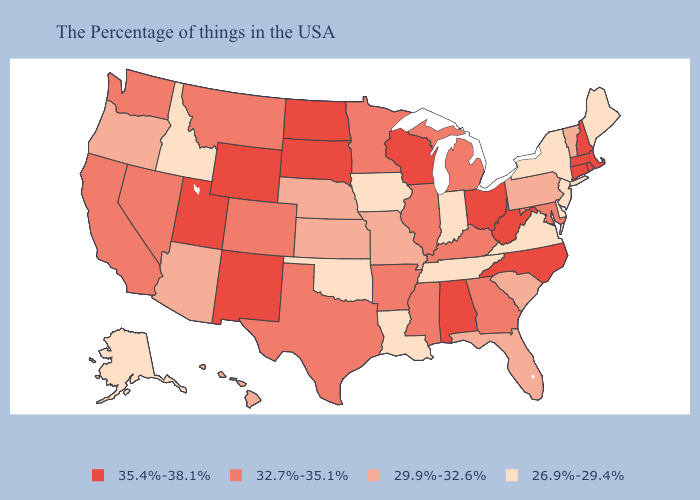Name the states that have a value in the range 29.9%-32.6%?
Be succinct. Vermont, Pennsylvania, South Carolina, Florida, Missouri, Kansas, Nebraska, Arizona, Oregon, Hawaii. Does Wyoming have a lower value than Kentucky?
Concise answer only. No. Which states hav the highest value in the South?
Answer briefly. North Carolina, West Virginia, Alabama. What is the value of Massachusetts?
Write a very short answer. 35.4%-38.1%. Does Maine have the lowest value in the Northeast?
Quick response, please. Yes. Name the states that have a value in the range 35.4%-38.1%?
Be succinct. Massachusetts, Rhode Island, New Hampshire, Connecticut, North Carolina, West Virginia, Ohio, Alabama, Wisconsin, South Dakota, North Dakota, Wyoming, New Mexico, Utah. How many symbols are there in the legend?
Short answer required. 4. Does Wyoming have the highest value in the West?
Be succinct. Yes. What is the value of Nevada?
Write a very short answer. 32.7%-35.1%. What is the lowest value in states that border Kansas?
Be succinct. 26.9%-29.4%. Does the map have missing data?
Be succinct. No. Does Alabama have the same value as North Dakota?
Be succinct. Yes. What is the lowest value in states that border Massachusetts?
Give a very brief answer. 26.9%-29.4%. Which states have the highest value in the USA?
Write a very short answer. Massachusetts, Rhode Island, New Hampshire, Connecticut, North Carolina, West Virginia, Ohio, Alabama, Wisconsin, South Dakota, North Dakota, Wyoming, New Mexico, Utah. What is the value of Kentucky?
Give a very brief answer. 32.7%-35.1%. 